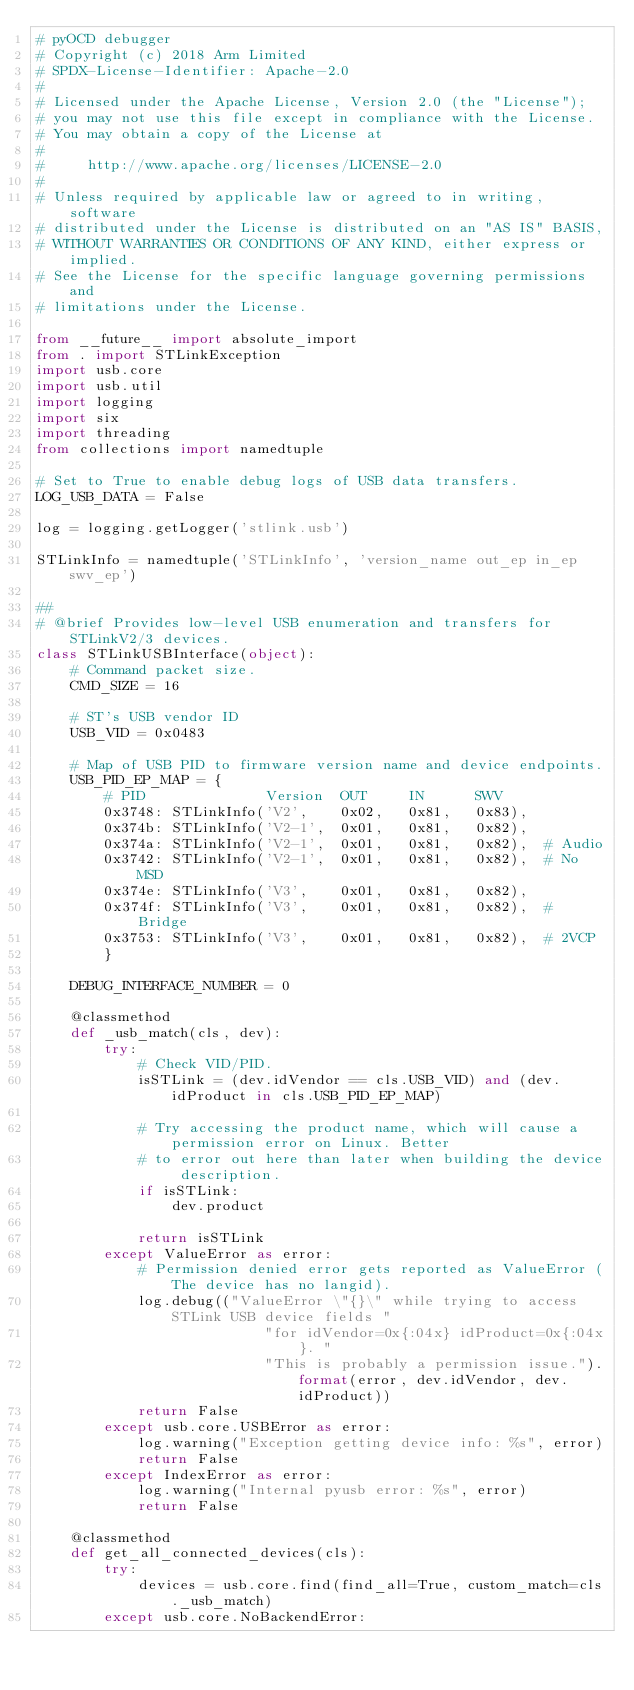<code> <loc_0><loc_0><loc_500><loc_500><_Python_># pyOCD debugger
# Copyright (c) 2018 Arm Limited
# SPDX-License-Identifier: Apache-2.0
#
# Licensed under the Apache License, Version 2.0 (the "License");
# you may not use this file except in compliance with the License.
# You may obtain a copy of the License at
#
#     http://www.apache.org/licenses/LICENSE-2.0
#
# Unless required by applicable law or agreed to in writing, software
# distributed under the License is distributed on an "AS IS" BASIS,
# WITHOUT WARRANTIES OR CONDITIONS OF ANY KIND, either express or implied.
# See the License for the specific language governing permissions and
# limitations under the License.

from __future__ import absolute_import
from . import STLinkException
import usb.core
import usb.util
import logging
import six
import threading
from collections import namedtuple

# Set to True to enable debug logs of USB data transfers.
LOG_USB_DATA = False

log = logging.getLogger('stlink.usb')

STLinkInfo = namedtuple('STLinkInfo', 'version_name out_ep in_ep swv_ep')

##
# @brief Provides low-level USB enumeration and transfers for STLinkV2/3 devices.
class STLinkUSBInterface(object):
    # Command packet size.
    CMD_SIZE = 16
    
    # ST's USB vendor ID
    USB_VID = 0x0483

    # Map of USB PID to firmware version name and device endpoints.
    USB_PID_EP_MAP = {
        # PID              Version  OUT     IN      SWV
        0x3748: STLinkInfo('V2',    0x02,   0x81,   0x83),
        0x374b: STLinkInfo('V2-1',  0x01,   0x81,   0x82),
        0x374a: STLinkInfo('V2-1',  0x01,   0x81,   0x82),  # Audio
        0x3742: STLinkInfo('V2-1',  0x01,   0x81,   0x82),  # No MSD
        0x374e: STLinkInfo('V3',    0x01,   0x81,   0x82),
        0x374f: STLinkInfo('V3',    0x01,   0x81,   0x82),  # Bridge
        0x3753: STLinkInfo('V3',    0x01,   0x81,   0x82),  # 2VCP
        }
    
    DEBUG_INTERFACE_NUMBER = 0

    @classmethod
    def _usb_match(cls, dev):
        try:
            # Check VID/PID.
            isSTLink = (dev.idVendor == cls.USB_VID) and (dev.idProduct in cls.USB_PID_EP_MAP)
            
            # Try accessing the product name, which will cause a permission error on Linux. Better
            # to error out here than later when building the device description.
            if isSTLink:
                dev.product
            
            return isSTLink
        except ValueError as error:
            # Permission denied error gets reported as ValueError (The device has no langid).
            log.debug(("ValueError \"{}\" while trying to access STLink USB device fields "
                           "for idVendor=0x{:04x} idProduct=0x{:04x}. "
                           "This is probably a permission issue.").format(error, dev.idVendor, dev.idProduct))
            return False
        except usb.core.USBError as error:
            log.warning("Exception getting device info: %s", error)
            return False
        except IndexError as error:
            log.warning("Internal pyusb error: %s", error)
            return False

    @classmethod
    def get_all_connected_devices(cls):
        try:
            devices = usb.core.find(find_all=True, custom_match=cls._usb_match)
        except usb.core.NoBackendError:</code> 